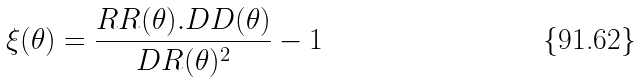<formula> <loc_0><loc_0><loc_500><loc_500>\xi ( \theta ) = \frac { R R ( \theta ) . D D ( \theta ) } { D R ( \theta ) ^ { 2 } } - 1</formula> 